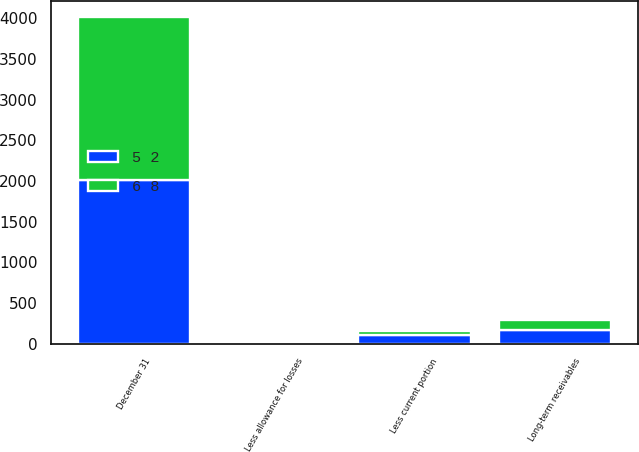Convert chart. <chart><loc_0><loc_0><loc_500><loc_500><stacked_bar_chart><ecel><fcel>December 31<fcel>Long-term receivables<fcel>Less allowance for losses<fcel>Less current portion<nl><fcel>5 2<fcel>2008<fcel>169<fcel>7<fcel>110<nl><fcel>6 8<fcel>2007<fcel>123<fcel>5<fcel>50<nl></chart> 